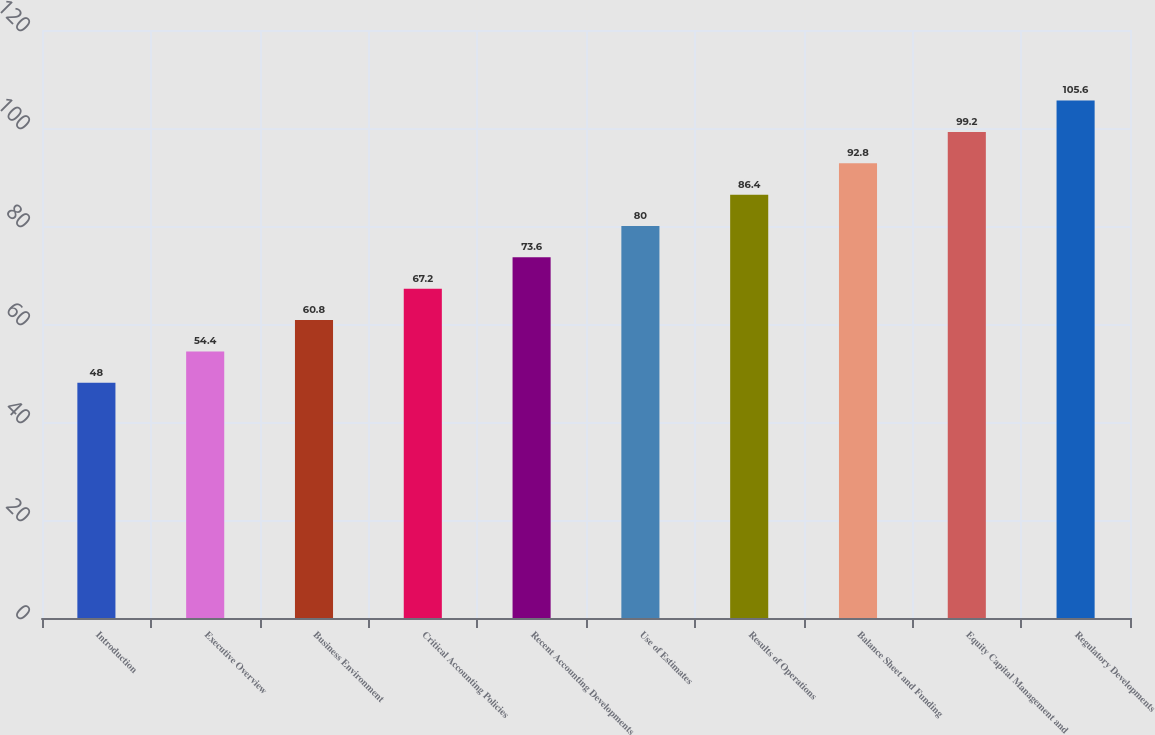Convert chart. <chart><loc_0><loc_0><loc_500><loc_500><bar_chart><fcel>Introduction<fcel>Executive Overview<fcel>Business Environment<fcel>Critical Accounting Policies<fcel>Recent Accounting Developments<fcel>Use of Estimates<fcel>Results of Operations<fcel>Balance Sheet and Funding<fcel>Equity Capital Management and<fcel>Regulatory Developments<nl><fcel>48<fcel>54.4<fcel>60.8<fcel>67.2<fcel>73.6<fcel>80<fcel>86.4<fcel>92.8<fcel>99.2<fcel>105.6<nl></chart> 